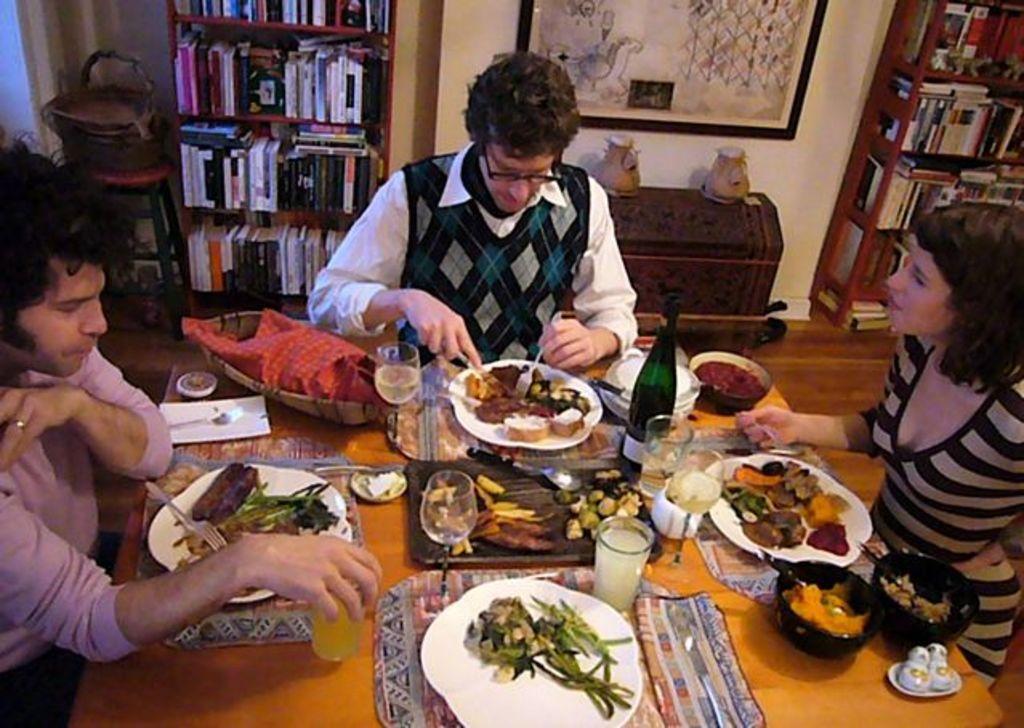Describe this image in one or two sentences. There are three persons sitting near the table. There are many food items on the table, plates, glasses, bottles and bowls. In the background we can see books shelf, photo frame and stool. 